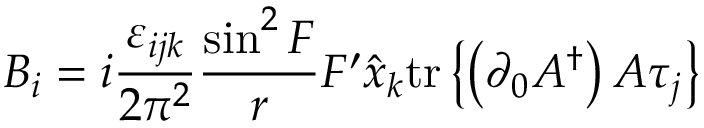Convert formula to latex. <formula><loc_0><loc_0><loc_500><loc_500>B _ { i } = i \frac { \varepsilon _ { i j k } } { 2 \pi ^ { 2 } } \frac { \sin ^ { 2 } F } { r } F ^ { \prime } \hat { x } _ { k } t r \left \{ \left ( \partial _ { 0 } A ^ { \dag } \right ) A \tau _ { j } \right \}</formula> 